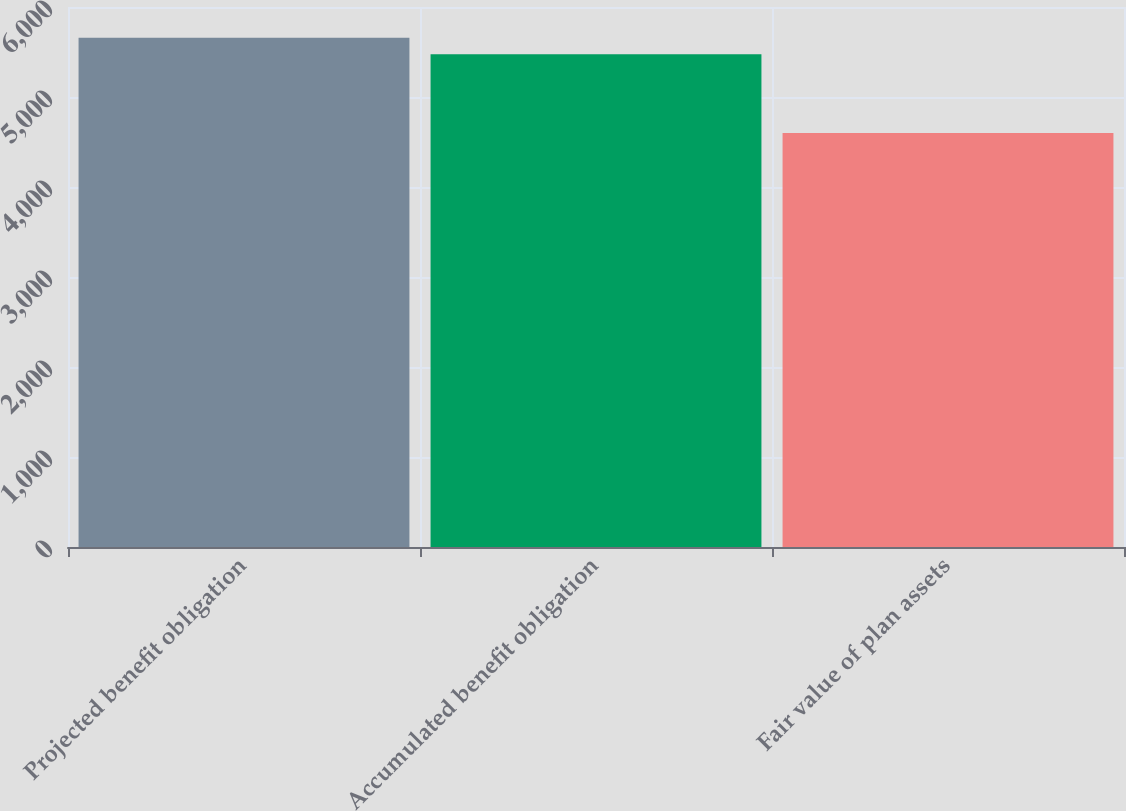Convert chart to OTSL. <chart><loc_0><loc_0><loc_500><loc_500><bar_chart><fcel>Projected benefit obligation<fcel>Accumulated benefit obligation<fcel>Fair value of plan assets<nl><fcel>5658<fcel>5475<fcel>4600<nl></chart> 